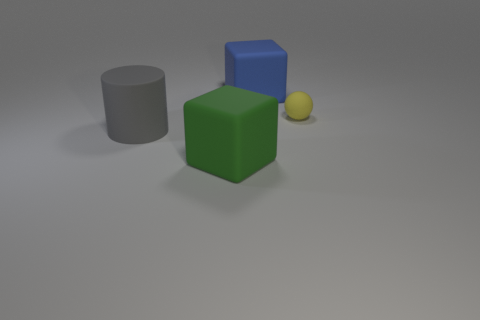Are there any other things that are the same shape as the small matte object?
Ensure brevity in your answer.  No. There is a large rubber block that is in front of the block that is on the right side of the block that is to the left of the blue rubber cube; what is its color?
Your answer should be very brief. Green. What number of small objects are gray matte things or red metallic objects?
Provide a succinct answer. 0. Are there the same number of yellow rubber spheres that are behind the green rubber cube and large gray cylinders?
Provide a succinct answer. Yes. There is a big green thing; are there any big green things in front of it?
Make the answer very short. No. How many rubber objects are either large cyan spheres or large blue blocks?
Your response must be concise. 1. There is a large gray rubber cylinder; how many large gray cylinders are behind it?
Give a very brief answer. 0. Are there any red shiny things of the same size as the yellow sphere?
Make the answer very short. No. Is there a large metallic block of the same color as the small thing?
Give a very brief answer. No. Are there any other things that have the same size as the green object?
Your answer should be compact. Yes. 